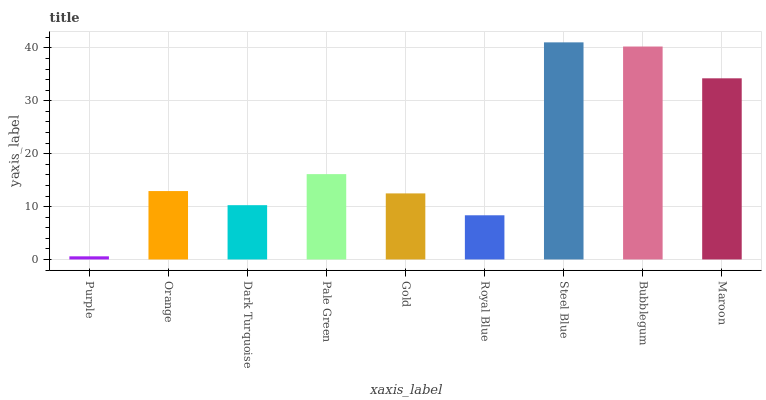Is Purple the minimum?
Answer yes or no. Yes. Is Steel Blue the maximum?
Answer yes or no. Yes. Is Orange the minimum?
Answer yes or no. No. Is Orange the maximum?
Answer yes or no. No. Is Orange greater than Purple?
Answer yes or no. Yes. Is Purple less than Orange?
Answer yes or no. Yes. Is Purple greater than Orange?
Answer yes or no. No. Is Orange less than Purple?
Answer yes or no. No. Is Orange the high median?
Answer yes or no. Yes. Is Orange the low median?
Answer yes or no. Yes. Is Maroon the high median?
Answer yes or no. No. Is Royal Blue the low median?
Answer yes or no. No. 